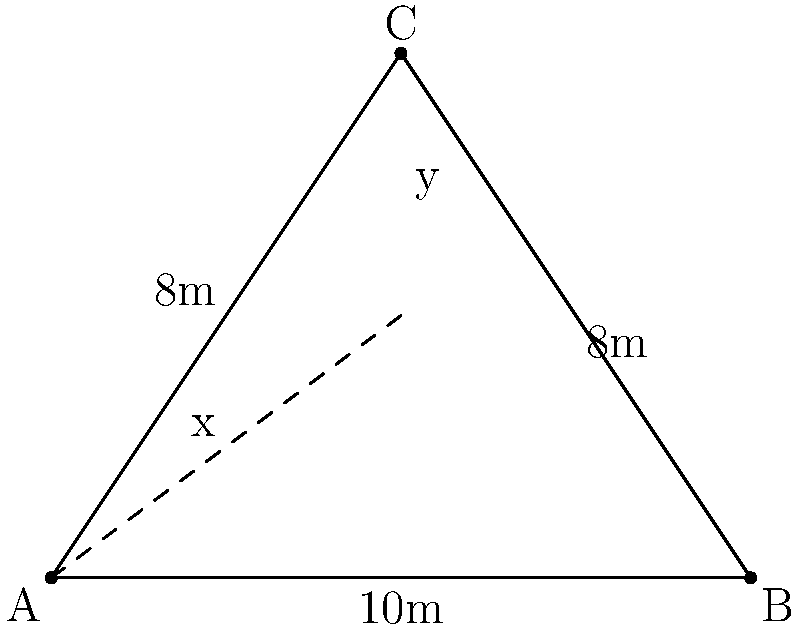A fuel truck is positioned at point A, and an aircraft needs refueling at point C. There's an obstacle at point B that the fuel hose must avoid. If AB = 10m, BC = 8m, and AC = 8m, what is the shortest path for the fuel hose from A to C that avoids the obstacle? Round your answer to the nearest centimeter. To find the shortest path, we need to determine the point on AB where the hose should bend to reach C. Let's call this point D.

Step 1: Let AD = x and DC = y. Our goal is to minimize x + y.

Step 2: Apply the Pythagorean theorem to triangle ACD:
$x^2 + 6^2 = 8^2$
$x^2 + 36 = 64$
$x^2 = 28$
$x = \sqrt{28} = 2\sqrt{7}$

Step 3: Calculate y using the Pythagorean theorem in triangle BCD:
$y^2 + 6^2 = 8^2$
$y^2 + 36 = 64$
$y^2 = 28$
$y = \sqrt{28} = 2\sqrt{7}$

Step 4: The total length of the path is:
$x + y = 2\sqrt{7} + 2\sqrt{7} = 4\sqrt{7}$

Step 5: Convert to meters:
$4\sqrt{7} \approx 10.583$ meters

Step 6: Round to the nearest centimeter:
10.58 meters
Answer: 10.58 meters 